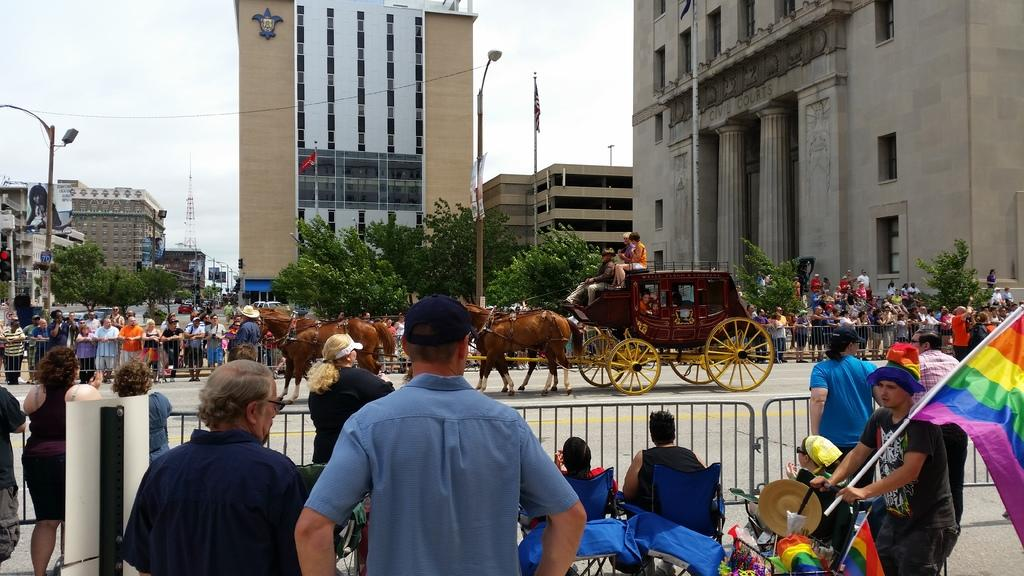What can be seen in the image? There are people standing in the image, along with a cart and animals. What is located in the background of the image? In the background of the image, there are buildings, the sky, a flag, trees, and a cell phone tower. Can you describe the cart in the image? The cart appears to be a type of vehicle or transportation method, but its specific details are not clear from the image. How many people are visible in the image? The number of people visible in the image is not specified, but there are at least a few people standing. What type of pizzas are being served to the mom on vacation in the image? There is no mention of pizzas, a mom, or a vacation in the image. The image features people, a cart, animals, and various background elements, but no pizzas or vacation-related context. 